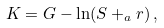Convert formula to latex. <formula><loc_0><loc_0><loc_500><loc_500>K = G - \ln ( S + _ { a } r ) \, ,</formula> 